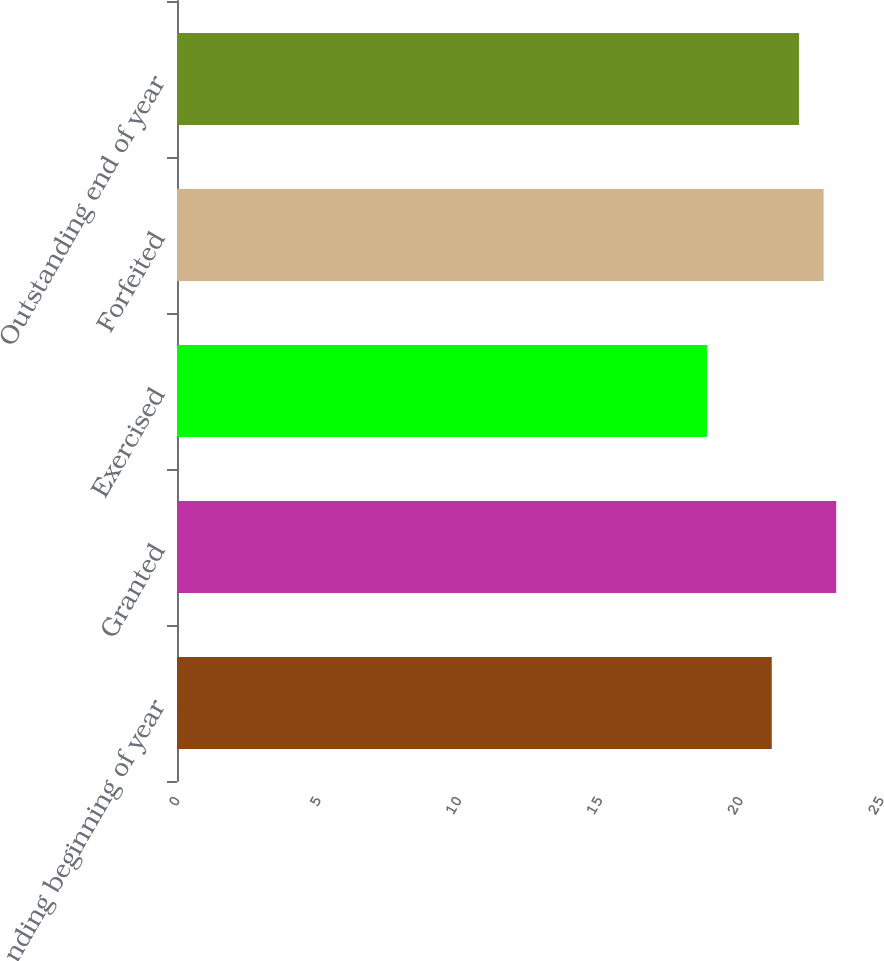Convert chart to OTSL. <chart><loc_0><loc_0><loc_500><loc_500><bar_chart><fcel>Outstanding beginning of year<fcel>Granted<fcel>Exercised<fcel>Forfeited<fcel>Outstanding end of year<nl><fcel>21.12<fcel>23.41<fcel>18.82<fcel>22.96<fcel>22.09<nl></chart> 